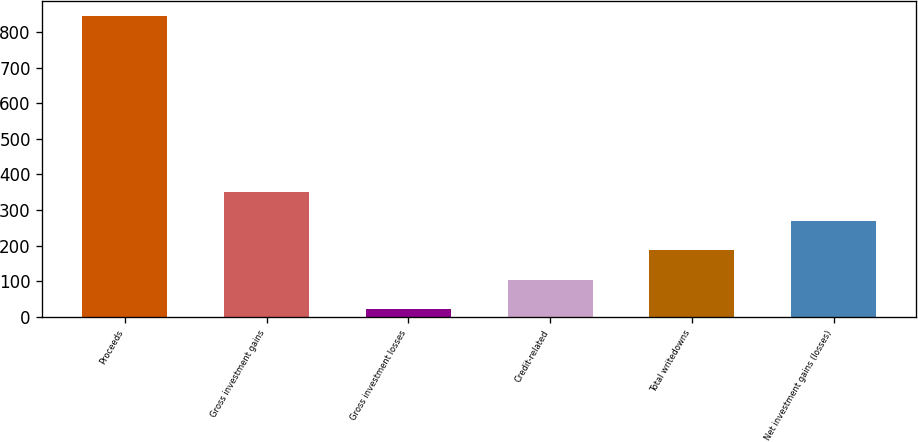<chart> <loc_0><loc_0><loc_500><loc_500><bar_chart><fcel>Proceeds<fcel>Gross investment gains<fcel>Gross investment losses<fcel>Credit-related<fcel>Total writedowns<fcel>Net investment gains (losses)<nl><fcel>845<fcel>351.2<fcel>22<fcel>104.3<fcel>186.6<fcel>268.9<nl></chart> 